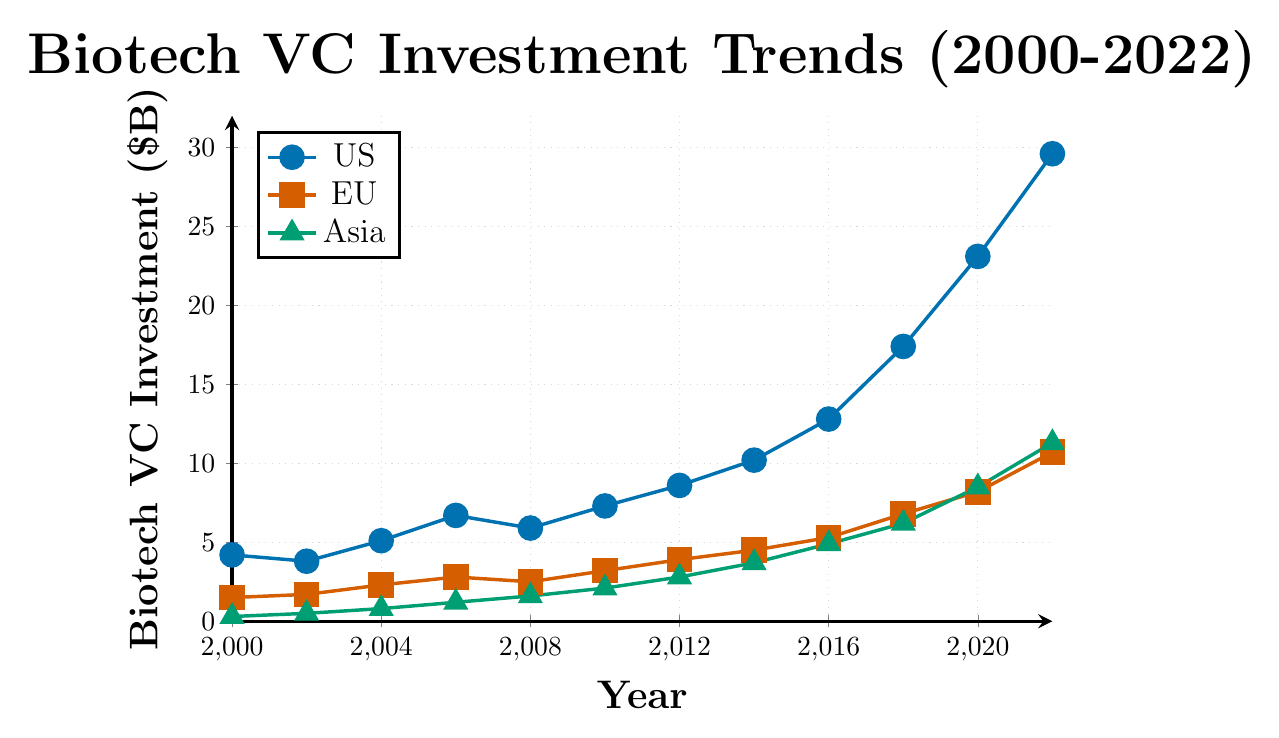Which market saw the highest growth in biotech VC investment from 2000 to 2022? The US market started at $4.2B in 2000 and increased to $29.6B in 2022, EU market grew from $1.5B to $10.7B, and Asia grew from $0.3B to $11.3B. The highest growth is in the US market, which increased by $25.4B.
Answer: US By how much did Asia's biotech VC investment increase between 2008 and 2020? Asia's investment was $1.6B in 2008 and $8.5B in 2020. So, the increase is $8.5B - $1.6B = $6.9B.
Answer: $6.9B What is the sum of the biotech VC investments in the US, EU, and Asia in 2018? In 2018, US investment was $17.4B, EU was $6.8B, and Asia was $6.2B. So, the sum is $17.4B + $6.8B + $6.2B = $30.4B.
Answer: $30.4B Which region had the smallest biotech VC investment in 2014? In 2014, US investment was $10.2B, EU was $4.5B, and Asia was $3.7B. Asia had the smallest investment among them.
Answer: Asia What is the average annual biotech VC investment in the EU from 2000 to 2022? EU investment is given for 12 years: 1.5, 1.7, 2.3, 2.8, 2.5, 3.2, 3.9, 4.5, 5.3, 6.8, 8.2, and 10.7. The sum is 53.4B. The average is 53.4 / 12 ≈ 4.45B.
Answer: 4.45B Did the biotech VC investment in the US ever decrease between consecutive years? If so, when? Comparing each consecutive year's US data, there's a decrease from 2000 to 2002 (4.2B to 3.8B) and from 2006 to 2008 (6.7B to 5.9B).
Answer: 2000-2002 and 2006-2008 Is the biotech VC investment in Asia higher than in the EU in 2022? In 2022, Asia's investment was $11.3B, while the EU's investment was $10.7B. Yes, Asia's investment is higher.
Answer: Yes What are the colors representing the US, EU, and Asia in the plot? The plot assigns different colors for each region: US is blue, EU is red, and Asia is green.
Answer: US: blue, EU: red, Asia: green By what percentage did US biotech VC investment increase from 2016 to 2022? US investment was $12.8B in 2016 and $29.6B in 2022. The increase is 29.6 - 12.8 = 16.8B. The percentage increase is (16.8 / 12.8) * 100 ≈ 131.25%.
Answer: 131.25% Which year saw the highest biotech VC investment in the EU and how much was it? The highest investment in the EU was in 2022 at $10.7B.
Answer: 2022, $10.7B 